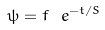<formula> <loc_0><loc_0><loc_500><loc_500>\psi = f \ e ^ { - t / S }</formula> 